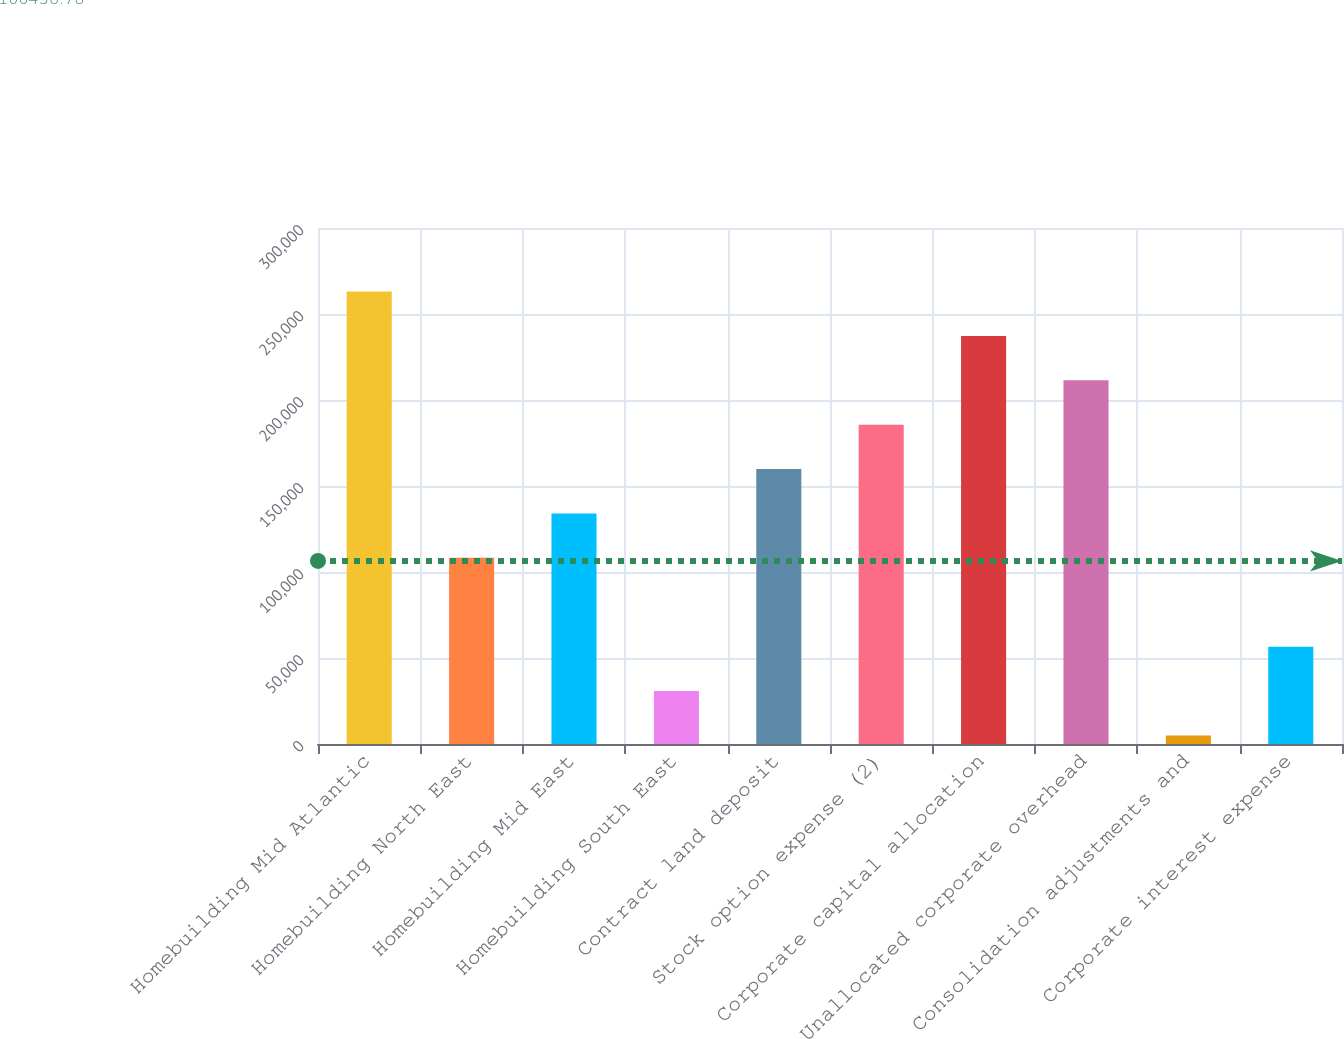Convert chart to OTSL. <chart><loc_0><loc_0><loc_500><loc_500><bar_chart><fcel>Homebuilding Mid Atlantic<fcel>Homebuilding North East<fcel>Homebuilding Mid East<fcel>Homebuilding South East<fcel>Contract land deposit<fcel>Stock option expense (2)<fcel>Corporate capital allocation<fcel>Unallocated corporate overhead<fcel>Consolidation adjustments and<fcel>Corporate interest expense<nl><fcel>263083<fcel>108215<fcel>134026<fcel>30781.3<fcel>159838<fcel>185649<fcel>237272<fcel>211460<fcel>4970<fcel>56592.6<nl></chart> 